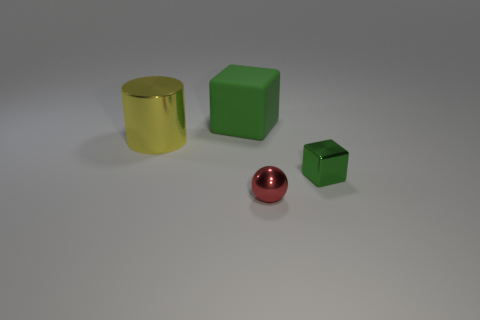Add 1 tiny metal objects. How many objects exist? 5 Subtract all cylinders. How many objects are left? 3 Add 1 large objects. How many large objects are left? 3 Add 1 small red rubber cubes. How many small red rubber cubes exist? 1 Subtract 0 gray cylinders. How many objects are left? 4 Subtract all tiny red matte cylinders. Subtract all yellow shiny cylinders. How many objects are left? 3 